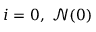Convert formula to latex. <formula><loc_0><loc_0><loc_500><loc_500>i = 0 , \ \mathcal { N } ( 0 )</formula> 